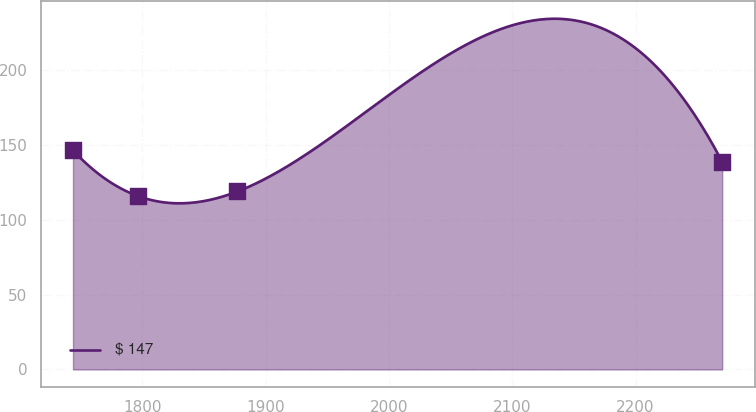Convert chart. <chart><loc_0><loc_0><loc_500><loc_500><line_chart><ecel><fcel>$ 147<nl><fcel>1743.87<fcel>146.28<nl><fcel>1796.51<fcel>115.77<nl><fcel>1877.16<fcel>118.82<nl><fcel>2270.23<fcel>138.58<nl></chart> 